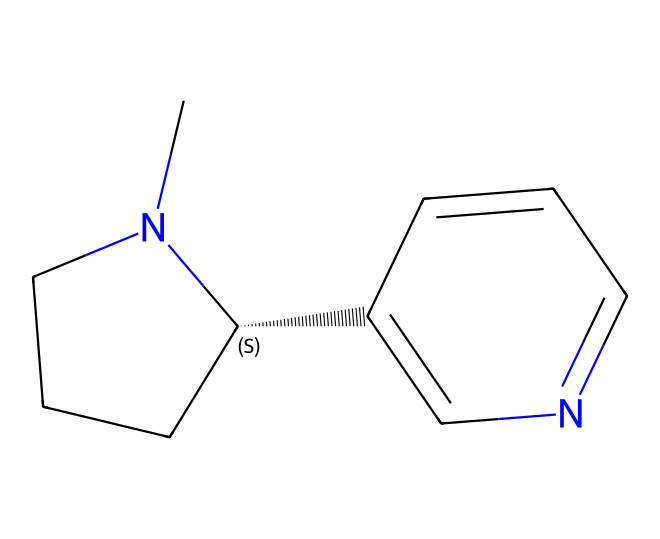What is the molecular formula of nicotine? By analyzing the SMILES representation, you can count the number of carbon (C), hydrogen (H), and nitrogen (N) atoms present. The structure CN1CCC[C@H]1C2=CN=CC=C2 contains 10 carbon atoms, 14 hydrogen atoms, and 2 nitrogen atoms. Therefore, the molecular formula is C10H14N2.
Answer: C10H14N2 How many rings are present in the nicotine structure? The SMILES string indicates that there are two cyclic structures here: the first is a piperidine ring (the CN1CCC[C@H]1 portion) and the second is an aromatic ring (the C2=CN=CC=C2 portion). Counting these rings gives us a total of two rings.
Answer: 2 What type of biological activity is associated with nicotine? The structure of nicotine contains a nitrogen atom, which is characteristic of alkaloids known for their biological effects, including stimulation of the central nervous system. This means nicotine is recognized for its role as a stimulant.
Answer: stimulant Does nicotine have any double bonds in its structure? In the SMILES notation, the "=" sign indicates the presence of double bonds. Looking through the structure, there are double bonds indicated in the aromatic ring (C2=CN=CC=C2) of the nicotine molecule. Thus, the answer is yes, there are double bonds in nicotine.
Answer: yes What are the potential effects of nicotine on poker players? Nicotine is known to act as a stimulant, which may enhance alertness and attention. This is particularly useful in poker, where focus and quick decision-making are crucial under pressure. Therefore, nicotine can potentially increase performance in high-stakes situations.
Answer: performance enhancement 